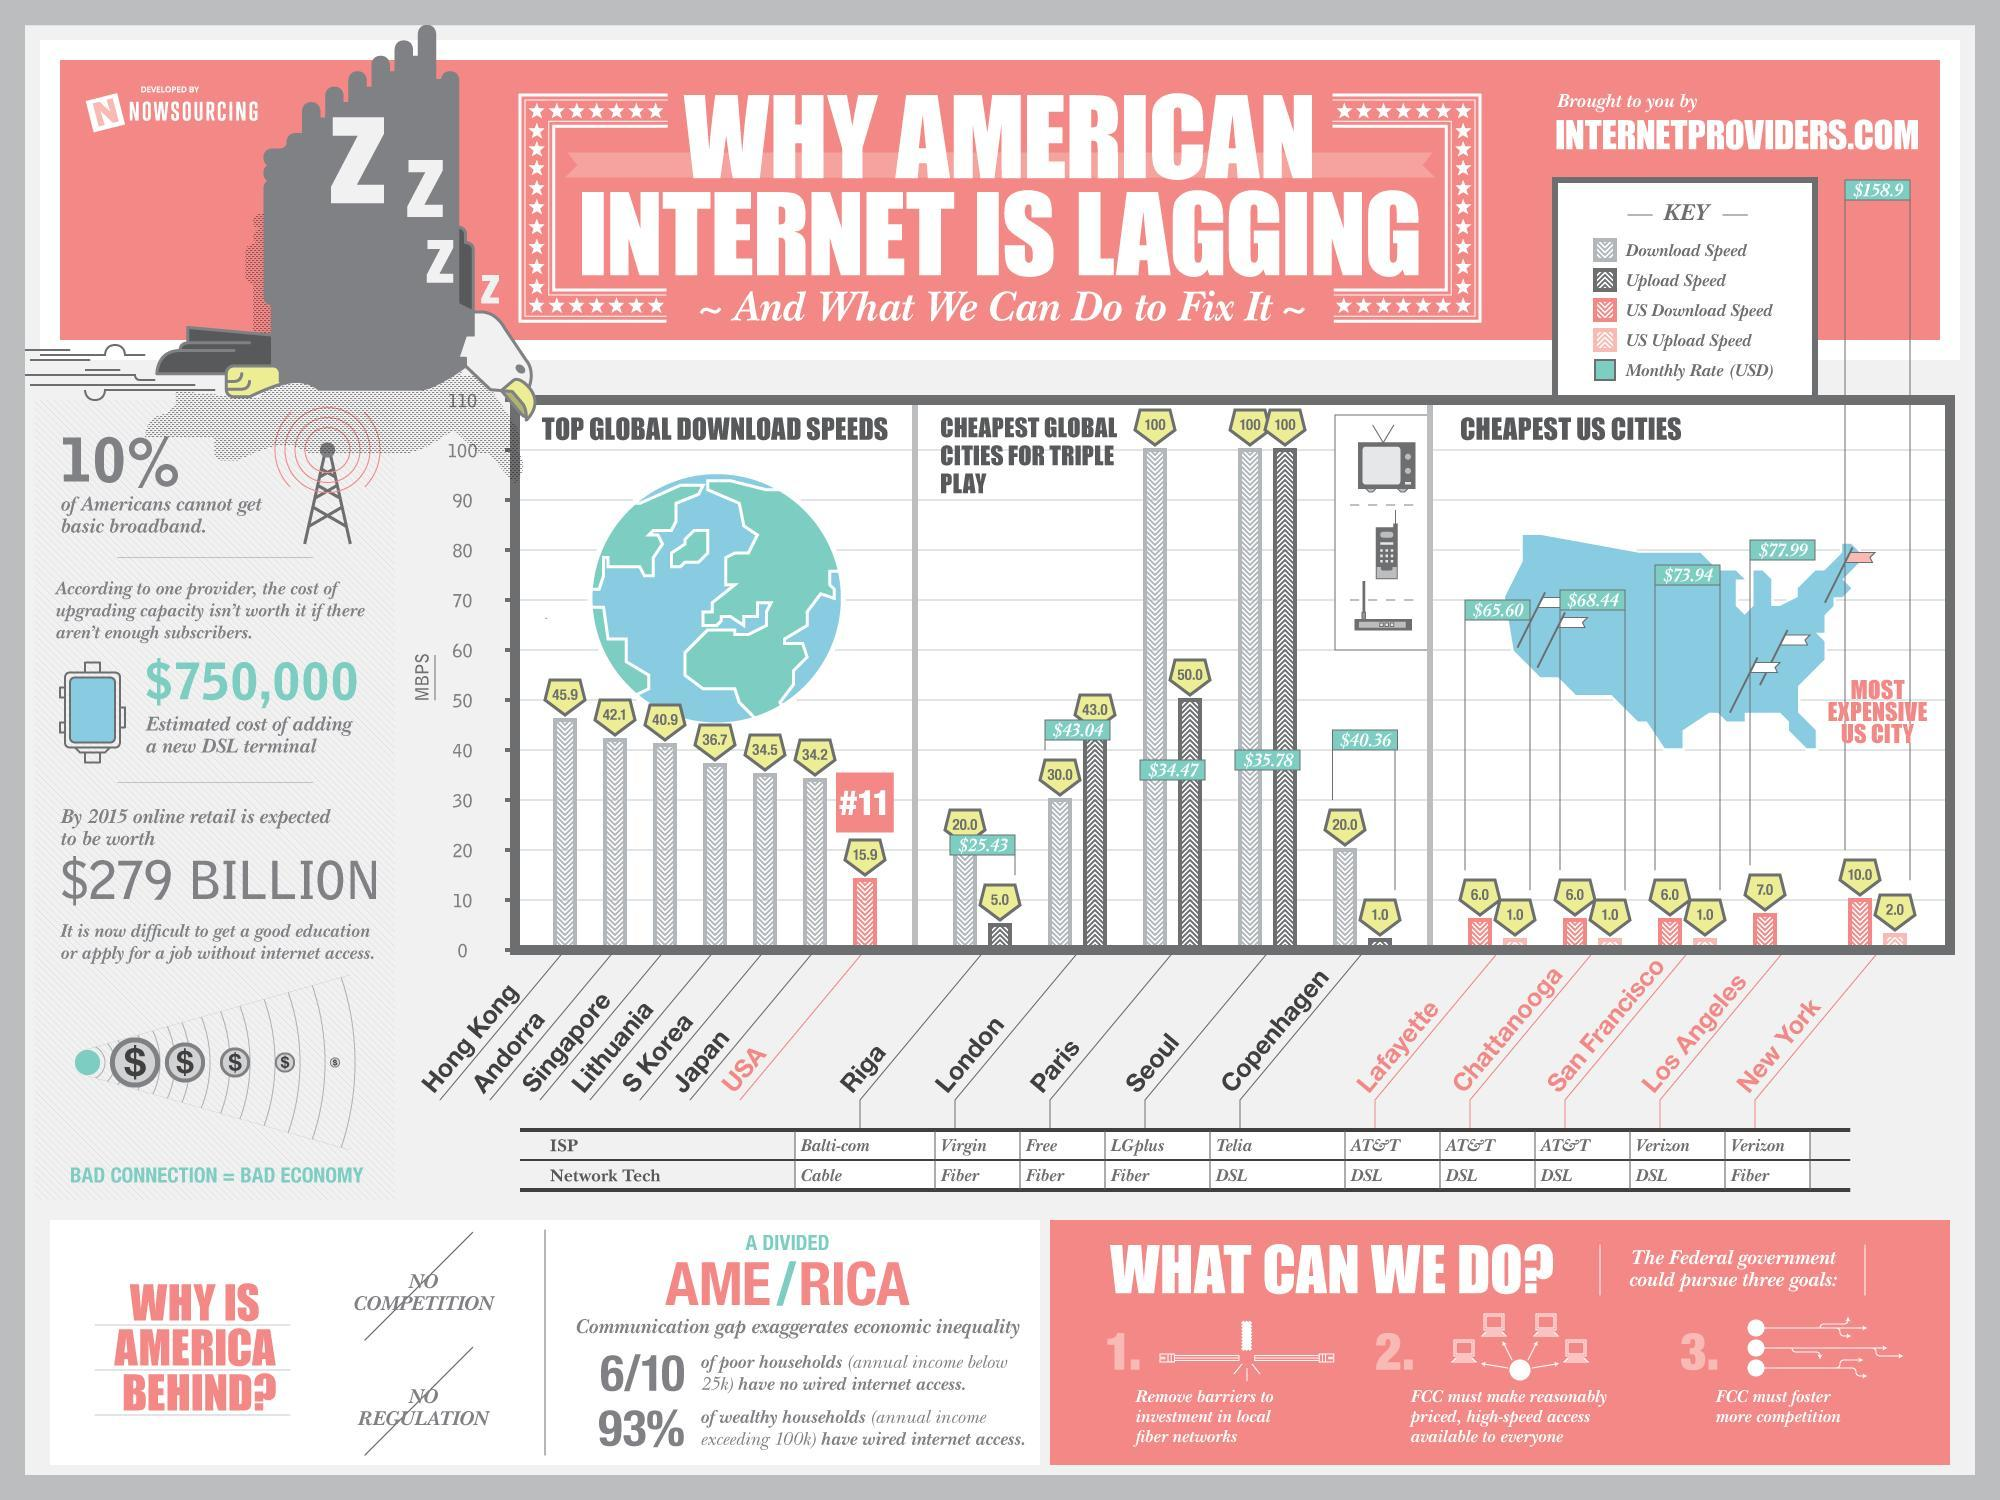Which city shows download speed and upload speed of 100 Mbps?
Answer the question with a short phrase. Seoul Which city has upload speed of 100 Mbps? Seoul How many global cities shown in the graph have download speed of 100 Mbps? 2 Which is the most expensive US city in terms of monthly internet rates? New York Which country is in third place in the top global download speeds graph? Singapore What is the monthly internet rate in Chattanooga? $68.44 Which global city has a monthly internet rate of 43.04 US Dollars? London What is the monthly internet rate in New York City? $158.9 Which global city shows a download speed of 2x times the upload speed? Paris At what position is USA in the top global download speeds list? 11 